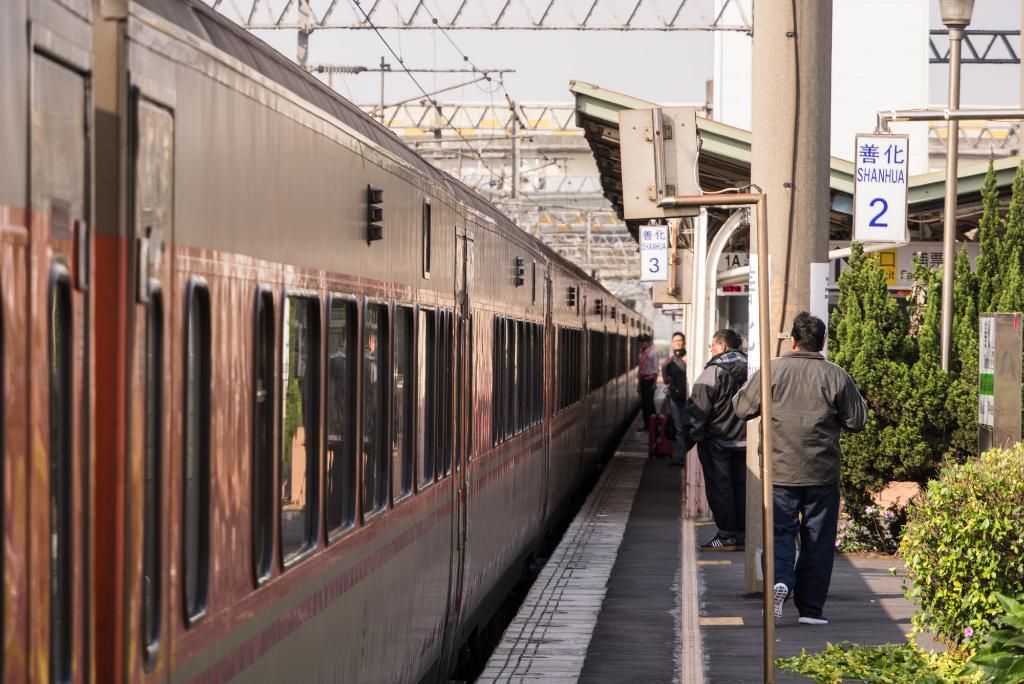Can you describe this image briefly? In this image we can see a few people on the platform, there are some poles, boards with text on it, there is a shed, we can see the train, there are plants, also we can see the sky. 